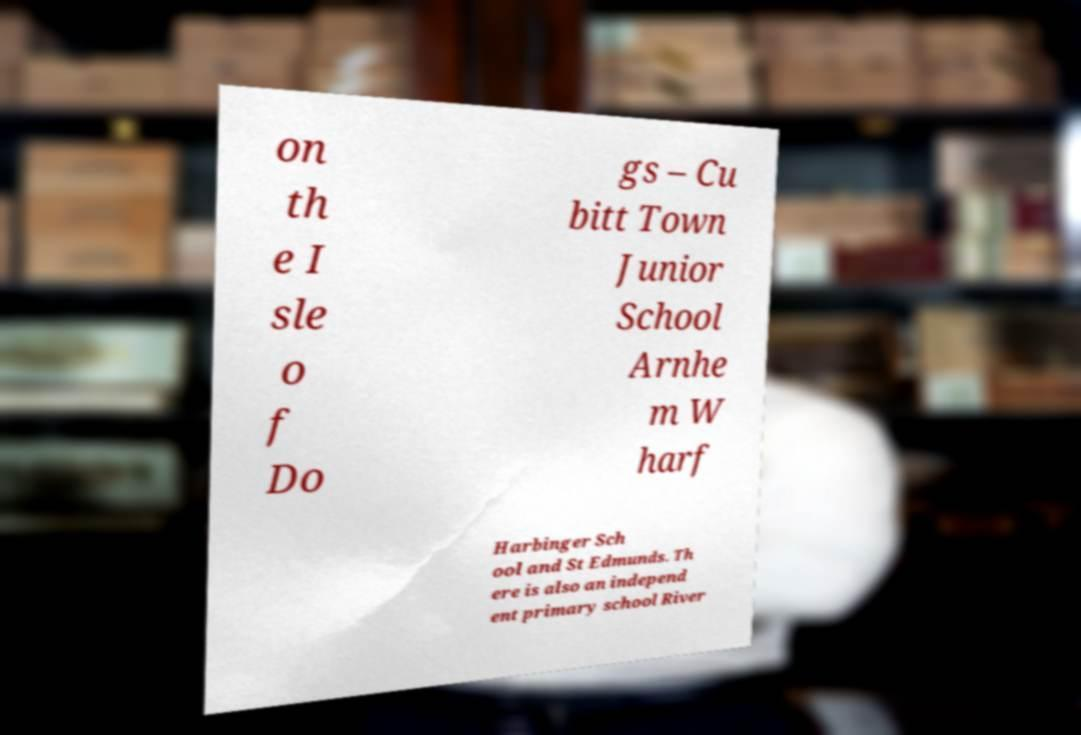Can you read and provide the text displayed in the image?This photo seems to have some interesting text. Can you extract and type it out for me? on th e I sle o f Do gs – Cu bitt Town Junior School Arnhe m W harf Harbinger Sch ool and St Edmunds. Th ere is also an independ ent primary school River 